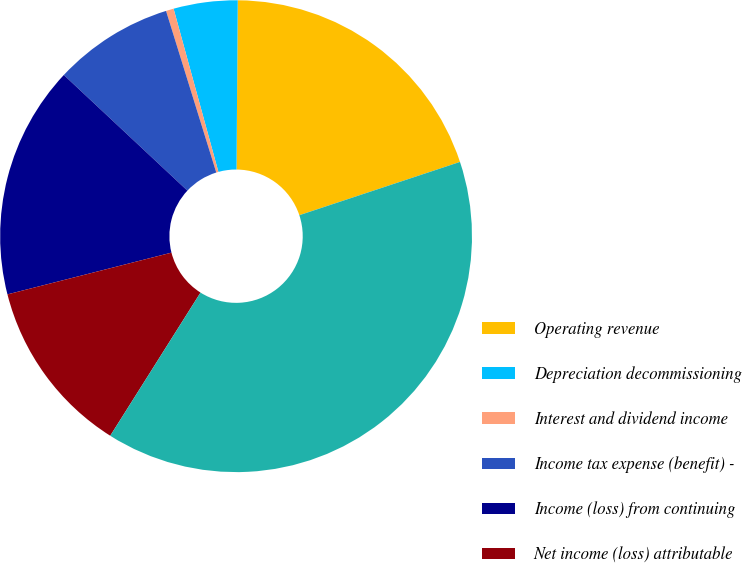<chart> <loc_0><loc_0><loc_500><loc_500><pie_chart><fcel>Operating revenue<fcel>Depreciation decommissioning<fcel>Interest and dividend income<fcel>Income tax expense (benefit) -<fcel>Income (loss) from continuing<fcel>Net income (loss) attributable<fcel>Total assets<nl><fcel>19.79%<fcel>4.38%<fcel>0.53%<fcel>8.23%<fcel>15.94%<fcel>12.08%<fcel>39.05%<nl></chart> 